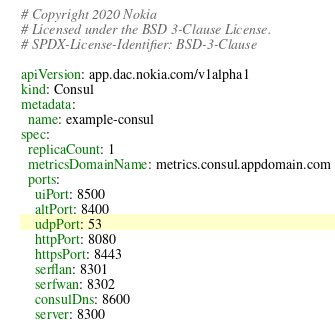Convert code to text. <code><loc_0><loc_0><loc_500><loc_500><_YAML_># Copyright 2020 Nokia
# Licensed under the BSD 3-Clause License.
# SPDX-License-Identifier: BSD-3-Clause

apiVersion: app.dac.nokia.com/v1alpha1
kind: Consul
metadata:
  name: example-consul
spec:
  replicaCount: 1
  metricsDomainName: metrics.consul.appdomain.com
  ports:
    uiPort: 8500
    altPort: 8400
    udpPort: 53
    httpPort: 8080
    httpsPort: 8443
    serflan: 8301
    serfwan: 8302
    consulDns: 8600
    server: 8300
</code> 